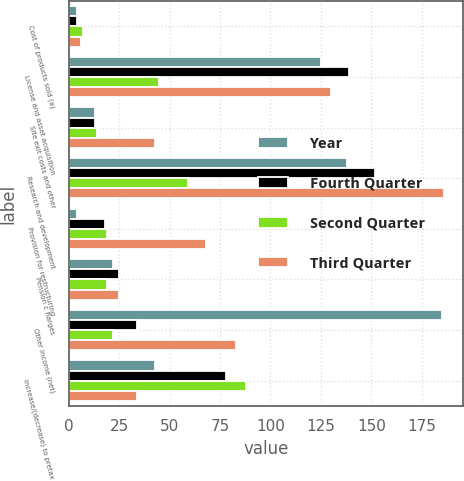Convert chart. <chart><loc_0><loc_0><loc_500><loc_500><stacked_bar_chart><ecel><fcel>Cost of products sold (a)<fcel>License and asset acquisition<fcel>Site exit costs and other<fcel>Research and development<fcel>Provision for restructuring<fcel>Pension c harges<fcel>Other income (net)<fcel>Increase/(decrease) to pretax<nl><fcel>Year<fcel>4<fcel>125<fcel>13<fcel>138<fcel>4<fcel>22<fcel>185<fcel>43<nl><fcel>Fourth Quarter<fcel>4<fcel>139<fcel>13<fcel>152<fcel>18<fcel>25<fcel>34<fcel>78<nl><fcel>Second Quarter<fcel>7<fcel>45<fcel>14<fcel>59<fcel>19<fcel>19<fcel>22<fcel>88<nl><fcel>Third Quarter<fcel>6<fcel>130<fcel>43<fcel>186<fcel>68<fcel>25<fcel>83<fcel>34<nl></chart> 